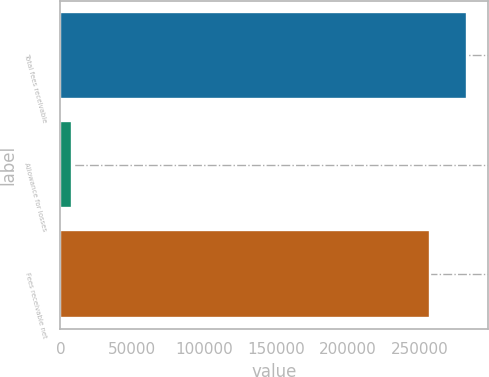Convert chart. <chart><loc_0><loc_0><loc_500><loc_500><bar_chart><fcel>Total fees receivable<fcel>Allowance for losses<fcel>Fees receivable net<nl><fcel>283458<fcel>8450<fcel>257689<nl></chart> 